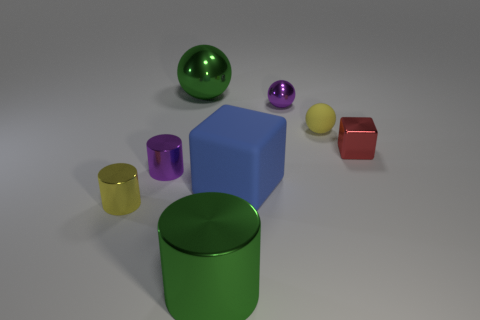Is the material of the big blue thing the same as the large green sphere?
Make the answer very short. No. There is a large metal object that is behind the yellow metal thing; what shape is it?
Provide a short and direct response. Sphere. There is a yellow object that is to the left of the small metal sphere; is there a green metallic object that is left of it?
Keep it short and to the point. No. Is there a yellow matte object that has the same size as the yellow metal cylinder?
Keep it short and to the point. Yes. There is a sphere that is on the left side of the big blue matte thing; is it the same color as the big metal cylinder?
Your answer should be compact. Yes. The matte ball is what size?
Give a very brief answer. Small. What size is the yellow thing that is right of the matte thing that is in front of the small purple cylinder?
Ensure brevity in your answer.  Small. How many other matte balls are the same color as the tiny matte ball?
Offer a very short reply. 0. What number of tiny yellow things are there?
Your answer should be compact. 2. What number of big cylinders are made of the same material as the tiny red object?
Offer a very short reply. 1. 